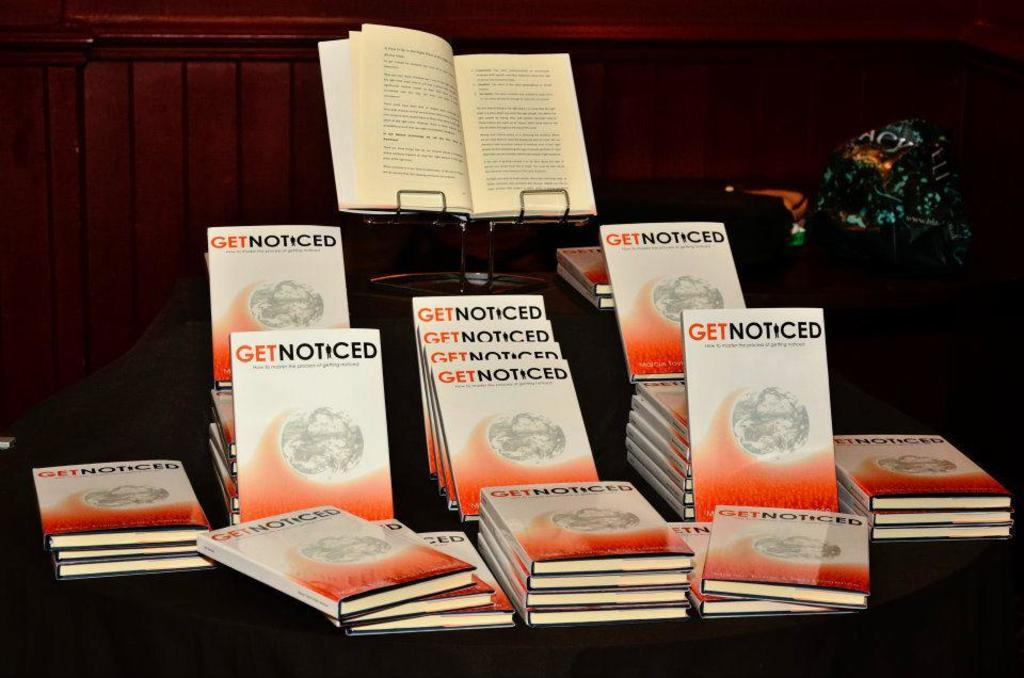<image>
Offer a succinct explanation of the picture presented. A book display containing many copies of the book Get Noticed. 